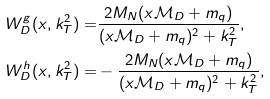<formula> <loc_0><loc_0><loc_500><loc_500>W _ { D } ^ { g } ( x , k _ { T } ^ { 2 } ) = & \frac { 2 M _ { N } ( x \mathcal { M } _ { D } + m _ { q } ) } { ( x \mathcal { M } _ { D } + m _ { q } ) ^ { 2 } + k _ { T } ^ { 2 } } , \\ W _ { D } ^ { h } ( x , k _ { T } ^ { 2 } ) = & - \frac { 2 M _ { N } ( x \mathcal { M } _ { D } + m _ { q } ) } { ( x \mathcal { M } _ { D } + m _ { q } ) ^ { 2 } + k _ { T } ^ { 2 } } ,</formula> 